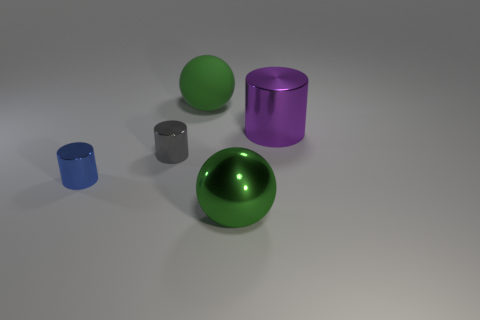Subtract all gray shiny cylinders. How many cylinders are left? 2 Add 3 small cylinders. How many objects exist? 8 Subtract all cylinders. How many objects are left? 2 Add 1 large spheres. How many large spheres are left? 3 Add 2 small blue rubber balls. How many small blue rubber balls exist? 2 Subtract 1 blue cylinders. How many objects are left? 4 Subtract all red spheres. Subtract all red cylinders. How many spheres are left? 2 Subtract all large green metallic balls. Subtract all large purple cylinders. How many objects are left? 3 